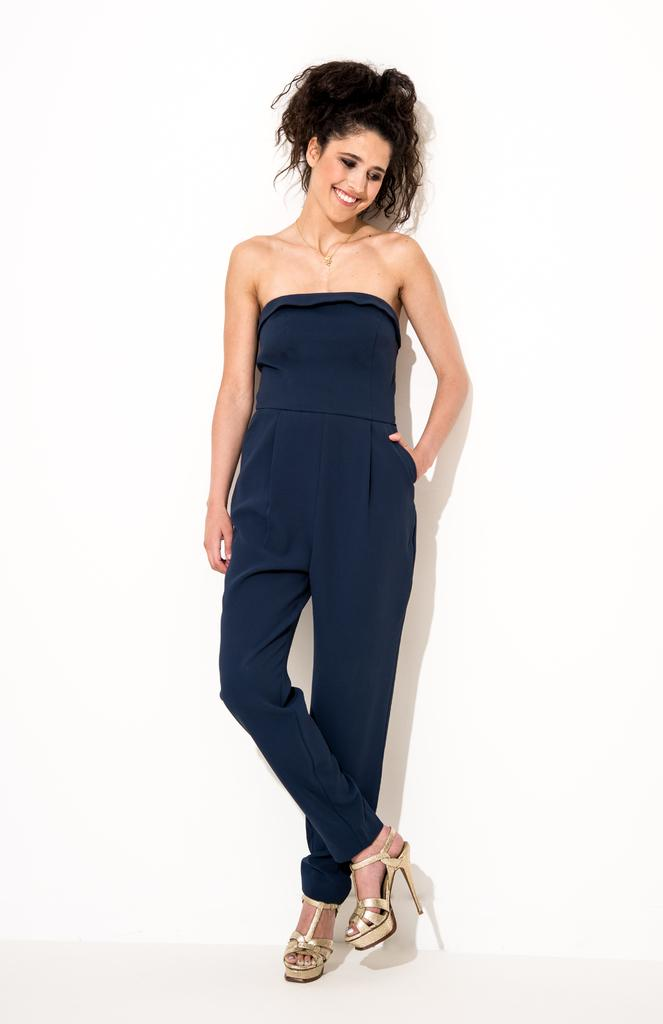What is the primary subject in the image? There is a woman in the image. What is the woman's position in relation to the floor? The woman is standing on the floor. What can be seen in the background of the image? There is a wall in the image. What type of desk is visible in the image? There is no desk present in the image. What kind of balls can be seen rolling on the floor in the image? There are no balls visible in the image. 